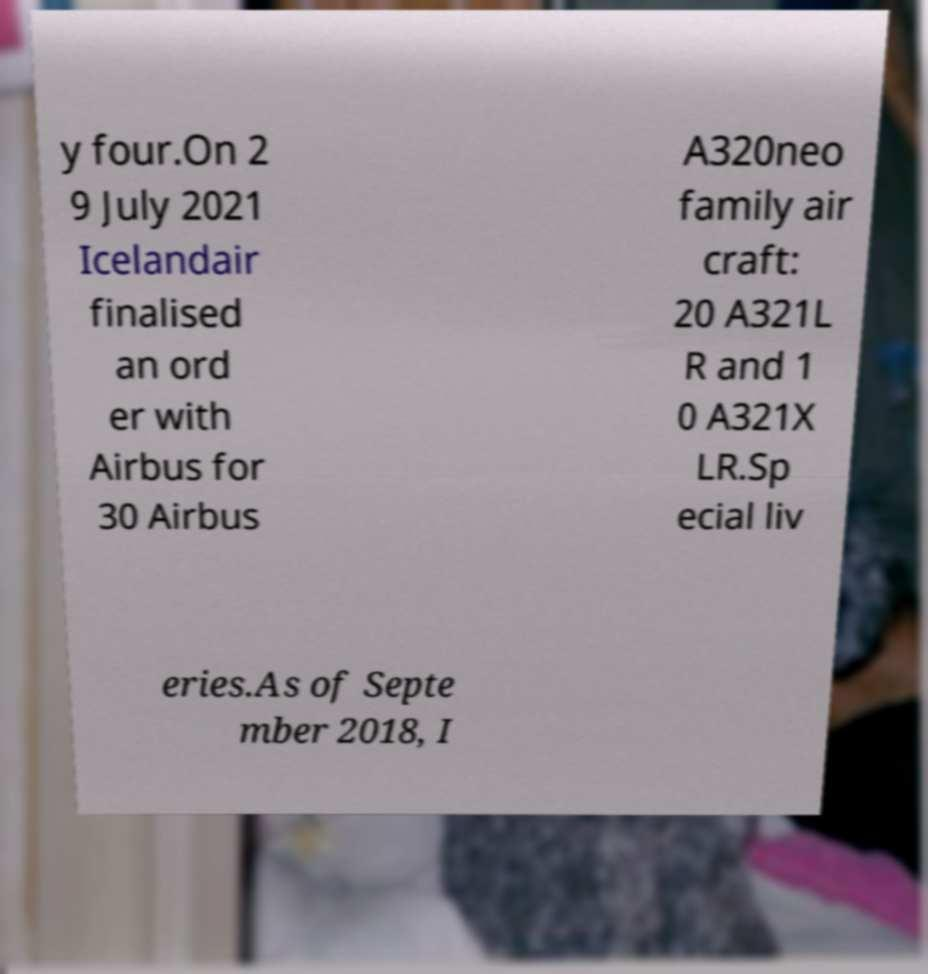Can you accurately transcribe the text from the provided image for me? y four.On 2 9 July 2021 Icelandair finalised an ord er with Airbus for 30 Airbus A320neo family air craft: 20 A321L R and 1 0 A321X LR.Sp ecial liv eries.As of Septe mber 2018, I 